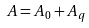Convert formula to latex. <formula><loc_0><loc_0><loc_500><loc_500>A = A _ { 0 } + A _ { q }</formula> 